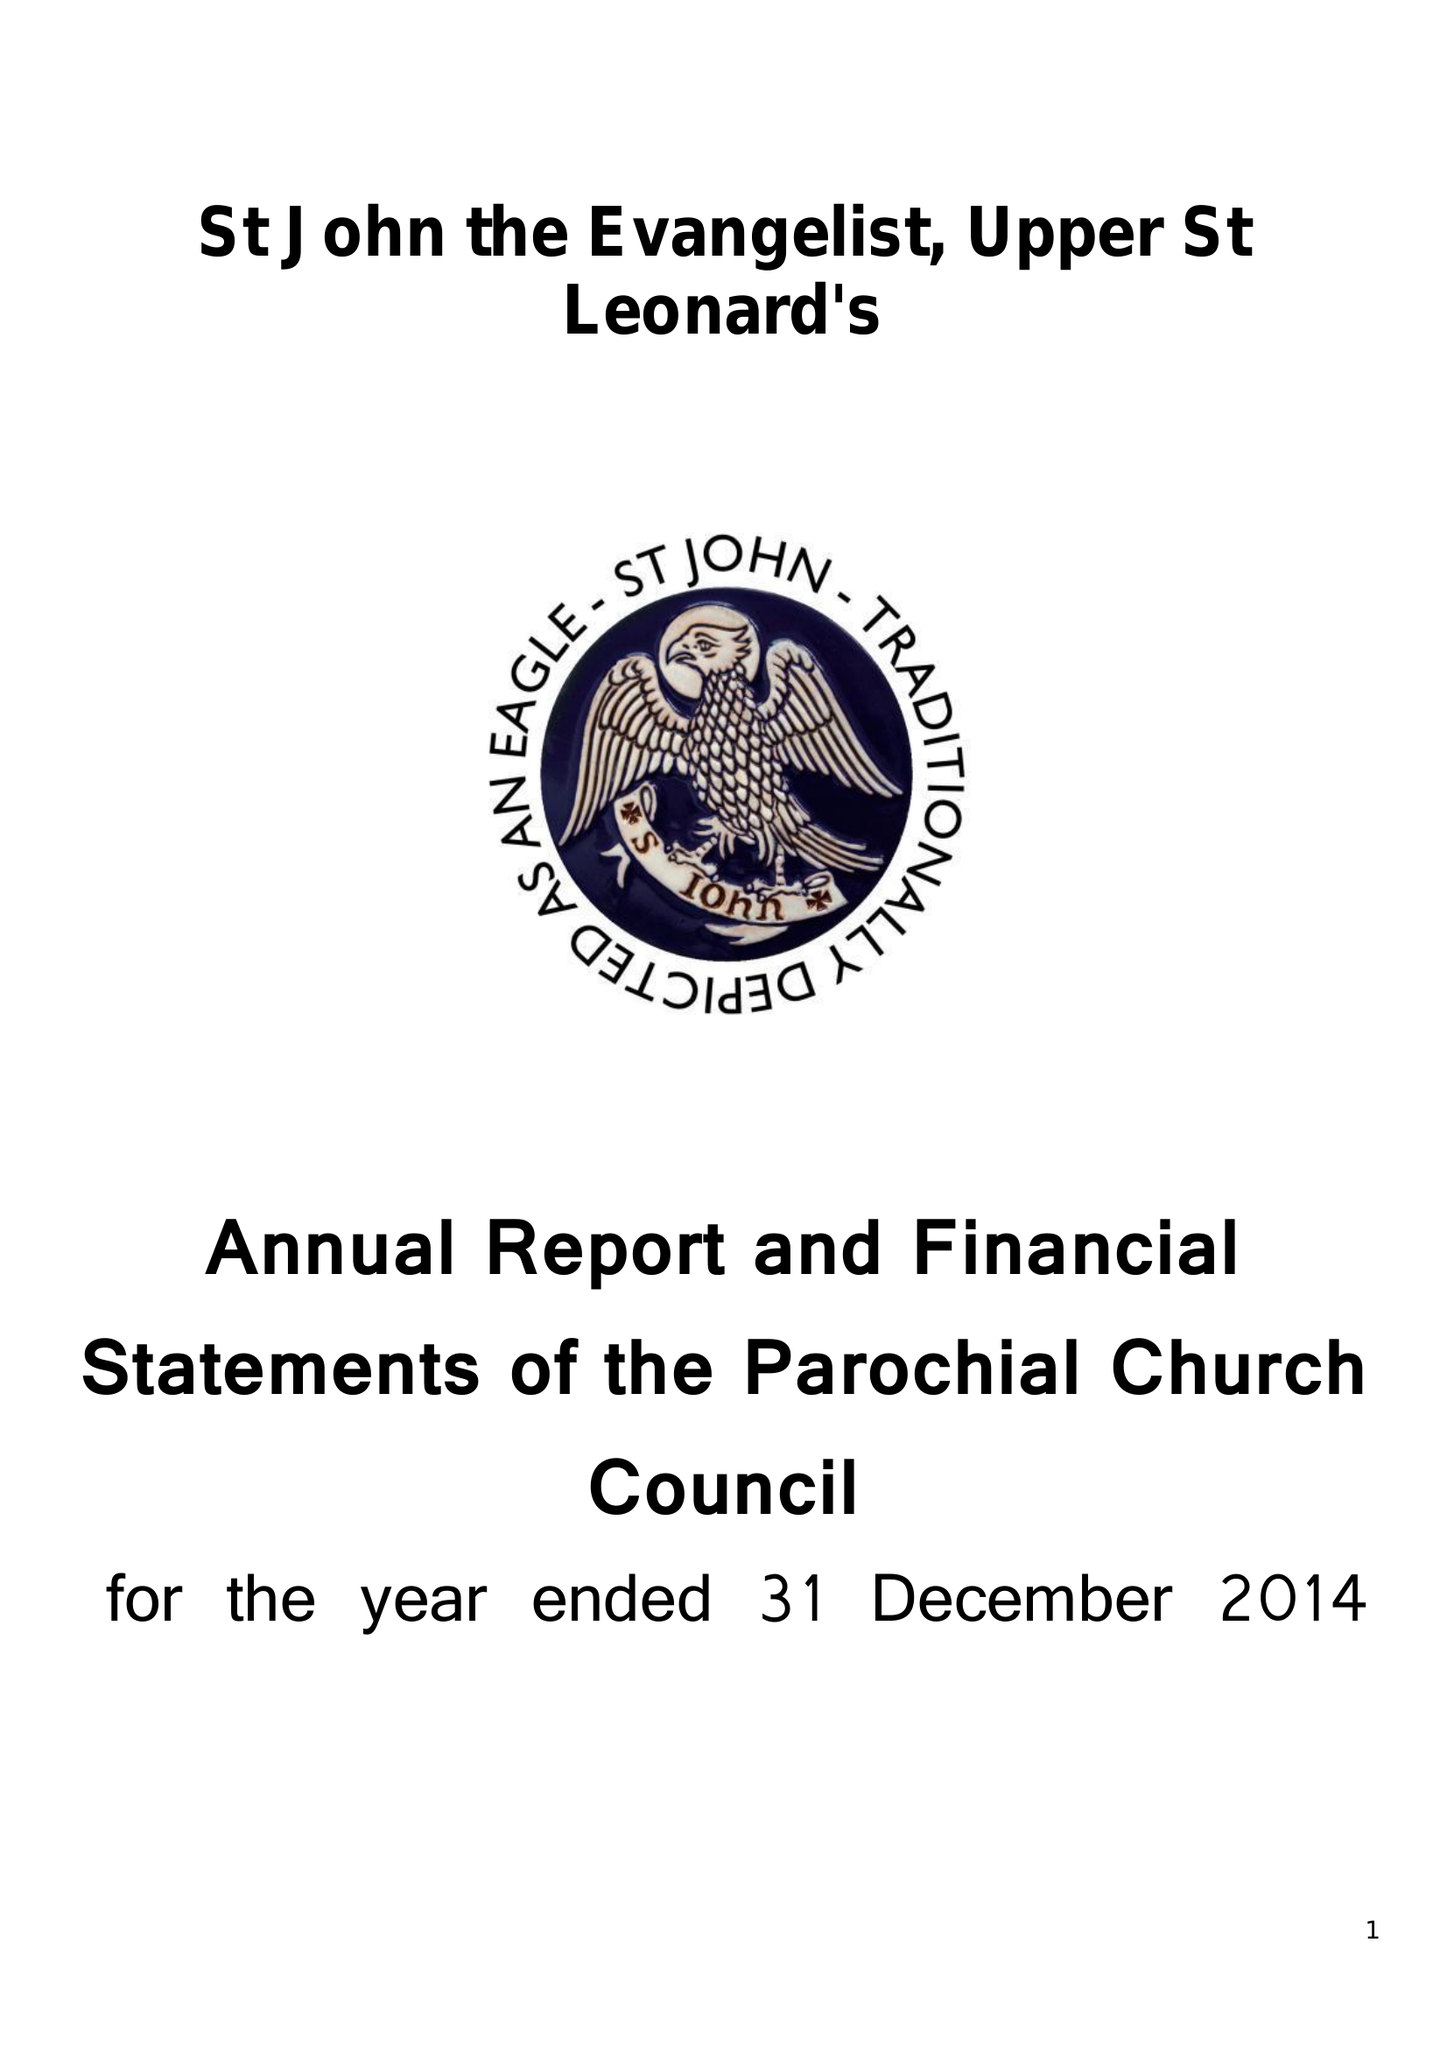What is the value for the address__post_town?
Answer the question using a single word or phrase. ST. LEONARDS-ON-SEA 